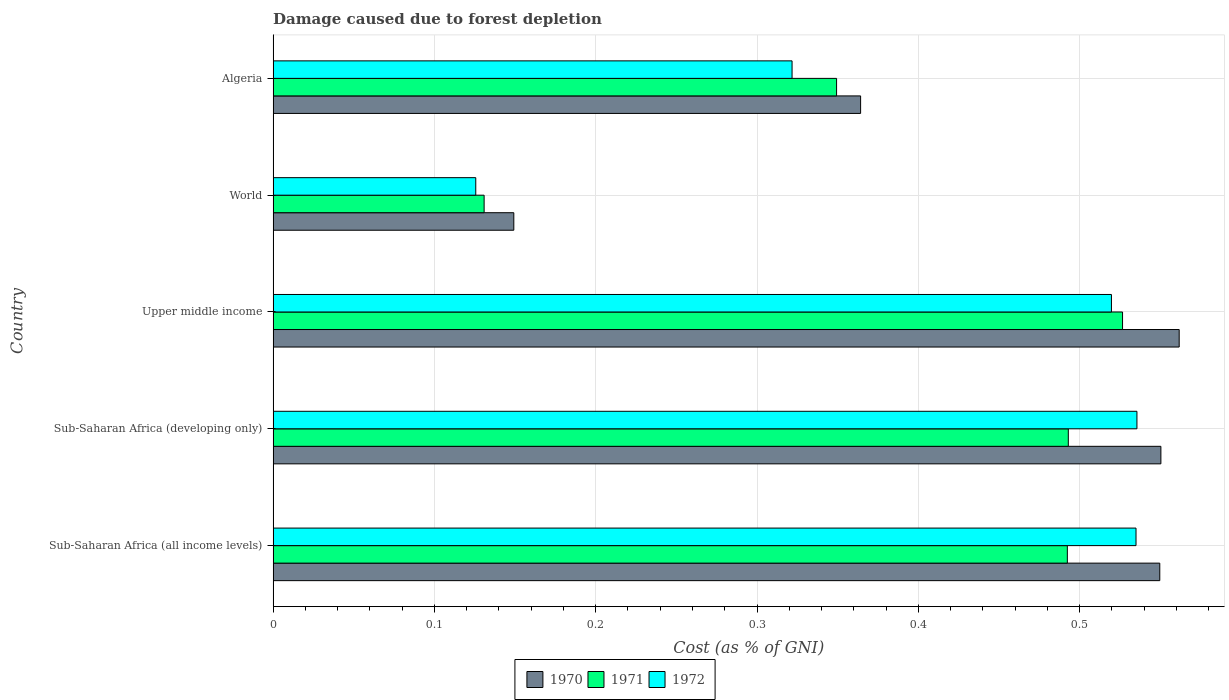How many different coloured bars are there?
Give a very brief answer. 3. How many bars are there on the 4th tick from the top?
Provide a short and direct response. 3. How many bars are there on the 4th tick from the bottom?
Your response must be concise. 3. What is the label of the 5th group of bars from the top?
Offer a terse response. Sub-Saharan Africa (all income levels). What is the cost of damage caused due to forest depletion in 1971 in World?
Provide a succinct answer. 0.13. Across all countries, what is the maximum cost of damage caused due to forest depletion in 1972?
Offer a terse response. 0.54. Across all countries, what is the minimum cost of damage caused due to forest depletion in 1970?
Make the answer very short. 0.15. In which country was the cost of damage caused due to forest depletion in 1970 maximum?
Keep it short and to the point. Upper middle income. What is the total cost of damage caused due to forest depletion in 1971 in the graph?
Your answer should be very brief. 1.99. What is the difference between the cost of damage caused due to forest depletion in 1971 in Sub-Saharan Africa (developing only) and that in World?
Your response must be concise. 0.36. What is the difference between the cost of damage caused due to forest depletion in 1971 in Sub-Saharan Africa (developing only) and the cost of damage caused due to forest depletion in 1970 in Sub-Saharan Africa (all income levels)?
Your response must be concise. -0.06. What is the average cost of damage caused due to forest depletion in 1971 per country?
Provide a short and direct response. 0.4. What is the difference between the cost of damage caused due to forest depletion in 1972 and cost of damage caused due to forest depletion in 1970 in Sub-Saharan Africa (all income levels)?
Provide a short and direct response. -0.01. In how many countries, is the cost of damage caused due to forest depletion in 1972 greater than 0.44 %?
Keep it short and to the point. 3. What is the ratio of the cost of damage caused due to forest depletion in 1970 in Sub-Saharan Africa (all income levels) to that in World?
Your answer should be compact. 3.68. Is the cost of damage caused due to forest depletion in 1972 in Sub-Saharan Africa (developing only) less than that in World?
Provide a succinct answer. No. What is the difference between the highest and the second highest cost of damage caused due to forest depletion in 1972?
Your response must be concise. 0. What is the difference between the highest and the lowest cost of damage caused due to forest depletion in 1972?
Give a very brief answer. 0.41. Is it the case that in every country, the sum of the cost of damage caused due to forest depletion in 1970 and cost of damage caused due to forest depletion in 1972 is greater than the cost of damage caused due to forest depletion in 1971?
Your response must be concise. Yes. How many bars are there?
Ensure brevity in your answer.  15. Are all the bars in the graph horizontal?
Offer a terse response. Yes. How many countries are there in the graph?
Offer a terse response. 5. Are the values on the major ticks of X-axis written in scientific E-notation?
Ensure brevity in your answer.  No. Where does the legend appear in the graph?
Your answer should be very brief. Bottom center. How many legend labels are there?
Provide a succinct answer. 3. What is the title of the graph?
Offer a terse response. Damage caused due to forest depletion. What is the label or title of the X-axis?
Provide a succinct answer. Cost (as % of GNI). What is the Cost (as % of GNI) in 1970 in Sub-Saharan Africa (all income levels)?
Your response must be concise. 0.55. What is the Cost (as % of GNI) of 1971 in Sub-Saharan Africa (all income levels)?
Provide a succinct answer. 0.49. What is the Cost (as % of GNI) in 1972 in Sub-Saharan Africa (all income levels)?
Keep it short and to the point. 0.53. What is the Cost (as % of GNI) in 1970 in Sub-Saharan Africa (developing only)?
Keep it short and to the point. 0.55. What is the Cost (as % of GNI) of 1971 in Sub-Saharan Africa (developing only)?
Give a very brief answer. 0.49. What is the Cost (as % of GNI) of 1972 in Sub-Saharan Africa (developing only)?
Make the answer very short. 0.54. What is the Cost (as % of GNI) of 1970 in Upper middle income?
Your answer should be very brief. 0.56. What is the Cost (as % of GNI) of 1971 in Upper middle income?
Your response must be concise. 0.53. What is the Cost (as % of GNI) of 1972 in Upper middle income?
Keep it short and to the point. 0.52. What is the Cost (as % of GNI) of 1970 in World?
Ensure brevity in your answer.  0.15. What is the Cost (as % of GNI) in 1971 in World?
Provide a succinct answer. 0.13. What is the Cost (as % of GNI) in 1972 in World?
Keep it short and to the point. 0.13. What is the Cost (as % of GNI) of 1970 in Algeria?
Ensure brevity in your answer.  0.36. What is the Cost (as % of GNI) of 1971 in Algeria?
Ensure brevity in your answer.  0.35. What is the Cost (as % of GNI) in 1972 in Algeria?
Offer a very short reply. 0.32. Across all countries, what is the maximum Cost (as % of GNI) of 1970?
Ensure brevity in your answer.  0.56. Across all countries, what is the maximum Cost (as % of GNI) in 1971?
Your answer should be compact. 0.53. Across all countries, what is the maximum Cost (as % of GNI) of 1972?
Your answer should be very brief. 0.54. Across all countries, what is the minimum Cost (as % of GNI) of 1970?
Your answer should be compact. 0.15. Across all countries, what is the minimum Cost (as % of GNI) of 1971?
Provide a succinct answer. 0.13. Across all countries, what is the minimum Cost (as % of GNI) in 1972?
Your answer should be compact. 0.13. What is the total Cost (as % of GNI) in 1970 in the graph?
Keep it short and to the point. 2.18. What is the total Cost (as % of GNI) of 1971 in the graph?
Your response must be concise. 1.99. What is the total Cost (as % of GNI) in 1972 in the graph?
Give a very brief answer. 2.04. What is the difference between the Cost (as % of GNI) in 1970 in Sub-Saharan Africa (all income levels) and that in Sub-Saharan Africa (developing only)?
Give a very brief answer. -0. What is the difference between the Cost (as % of GNI) in 1971 in Sub-Saharan Africa (all income levels) and that in Sub-Saharan Africa (developing only)?
Your answer should be compact. -0. What is the difference between the Cost (as % of GNI) of 1972 in Sub-Saharan Africa (all income levels) and that in Sub-Saharan Africa (developing only)?
Your answer should be very brief. -0. What is the difference between the Cost (as % of GNI) in 1970 in Sub-Saharan Africa (all income levels) and that in Upper middle income?
Make the answer very short. -0.01. What is the difference between the Cost (as % of GNI) in 1971 in Sub-Saharan Africa (all income levels) and that in Upper middle income?
Give a very brief answer. -0.03. What is the difference between the Cost (as % of GNI) of 1972 in Sub-Saharan Africa (all income levels) and that in Upper middle income?
Make the answer very short. 0.02. What is the difference between the Cost (as % of GNI) of 1970 in Sub-Saharan Africa (all income levels) and that in World?
Keep it short and to the point. 0.4. What is the difference between the Cost (as % of GNI) of 1971 in Sub-Saharan Africa (all income levels) and that in World?
Provide a succinct answer. 0.36. What is the difference between the Cost (as % of GNI) in 1972 in Sub-Saharan Africa (all income levels) and that in World?
Provide a succinct answer. 0.41. What is the difference between the Cost (as % of GNI) in 1970 in Sub-Saharan Africa (all income levels) and that in Algeria?
Ensure brevity in your answer.  0.19. What is the difference between the Cost (as % of GNI) in 1971 in Sub-Saharan Africa (all income levels) and that in Algeria?
Provide a succinct answer. 0.14. What is the difference between the Cost (as % of GNI) of 1972 in Sub-Saharan Africa (all income levels) and that in Algeria?
Keep it short and to the point. 0.21. What is the difference between the Cost (as % of GNI) of 1970 in Sub-Saharan Africa (developing only) and that in Upper middle income?
Keep it short and to the point. -0.01. What is the difference between the Cost (as % of GNI) of 1971 in Sub-Saharan Africa (developing only) and that in Upper middle income?
Your answer should be very brief. -0.03. What is the difference between the Cost (as % of GNI) of 1972 in Sub-Saharan Africa (developing only) and that in Upper middle income?
Give a very brief answer. 0.02. What is the difference between the Cost (as % of GNI) in 1970 in Sub-Saharan Africa (developing only) and that in World?
Offer a terse response. 0.4. What is the difference between the Cost (as % of GNI) in 1971 in Sub-Saharan Africa (developing only) and that in World?
Keep it short and to the point. 0.36. What is the difference between the Cost (as % of GNI) in 1972 in Sub-Saharan Africa (developing only) and that in World?
Your answer should be compact. 0.41. What is the difference between the Cost (as % of GNI) of 1970 in Sub-Saharan Africa (developing only) and that in Algeria?
Make the answer very short. 0.19. What is the difference between the Cost (as % of GNI) of 1971 in Sub-Saharan Africa (developing only) and that in Algeria?
Your answer should be compact. 0.14. What is the difference between the Cost (as % of GNI) in 1972 in Sub-Saharan Africa (developing only) and that in Algeria?
Your answer should be compact. 0.21. What is the difference between the Cost (as % of GNI) in 1970 in Upper middle income and that in World?
Offer a very short reply. 0.41. What is the difference between the Cost (as % of GNI) in 1971 in Upper middle income and that in World?
Keep it short and to the point. 0.4. What is the difference between the Cost (as % of GNI) in 1972 in Upper middle income and that in World?
Offer a very short reply. 0.39. What is the difference between the Cost (as % of GNI) of 1970 in Upper middle income and that in Algeria?
Offer a very short reply. 0.2. What is the difference between the Cost (as % of GNI) of 1971 in Upper middle income and that in Algeria?
Ensure brevity in your answer.  0.18. What is the difference between the Cost (as % of GNI) of 1972 in Upper middle income and that in Algeria?
Provide a short and direct response. 0.2. What is the difference between the Cost (as % of GNI) of 1970 in World and that in Algeria?
Keep it short and to the point. -0.21. What is the difference between the Cost (as % of GNI) in 1971 in World and that in Algeria?
Your answer should be compact. -0.22. What is the difference between the Cost (as % of GNI) of 1972 in World and that in Algeria?
Your answer should be compact. -0.2. What is the difference between the Cost (as % of GNI) in 1970 in Sub-Saharan Africa (all income levels) and the Cost (as % of GNI) in 1971 in Sub-Saharan Africa (developing only)?
Offer a terse response. 0.06. What is the difference between the Cost (as % of GNI) in 1970 in Sub-Saharan Africa (all income levels) and the Cost (as % of GNI) in 1972 in Sub-Saharan Africa (developing only)?
Offer a terse response. 0.01. What is the difference between the Cost (as % of GNI) in 1971 in Sub-Saharan Africa (all income levels) and the Cost (as % of GNI) in 1972 in Sub-Saharan Africa (developing only)?
Your answer should be compact. -0.04. What is the difference between the Cost (as % of GNI) in 1970 in Sub-Saharan Africa (all income levels) and the Cost (as % of GNI) in 1971 in Upper middle income?
Your answer should be very brief. 0.02. What is the difference between the Cost (as % of GNI) of 1970 in Sub-Saharan Africa (all income levels) and the Cost (as % of GNI) of 1972 in Upper middle income?
Your answer should be compact. 0.03. What is the difference between the Cost (as % of GNI) in 1971 in Sub-Saharan Africa (all income levels) and the Cost (as % of GNI) in 1972 in Upper middle income?
Your answer should be very brief. -0.03. What is the difference between the Cost (as % of GNI) in 1970 in Sub-Saharan Africa (all income levels) and the Cost (as % of GNI) in 1971 in World?
Offer a terse response. 0.42. What is the difference between the Cost (as % of GNI) of 1970 in Sub-Saharan Africa (all income levels) and the Cost (as % of GNI) of 1972 in World?
Offer a terse response. 0.42. What is the difference between the Cost (as % of GNI) of 1971 in Sub-Saharan Africa (all income levels) and the Cost (as % of GNI) of 1972 in World?
Give a very brief answer. 0.37. What is the difference between the Cost (as % of GNI) of 1970 in Sub-Saharan Africa (all income levels) and the Cost (as % of GNI) of 1971 in Algeria?
Your answer should be very brief. 0.2. What is the difference between the Cost (as % of GNI) of 1970 in Sub-Saharan Africa (all income levels) and the Cost (as % of GNI) of 1972 in Algeria?
Your response must be concise. 0.23. What is the difference between the Cost (as % of GNI) of 1971 in Sub-Saharan Africa (all income levels) and the Cost (as % of GNI) of 1972 in Algeria?
Your response must be concise. 0.17. What is the difference between the Cost (as % of GNI) of 1970 in Sub-Saharan Africa (developing only) and the Cost (as % of GNI) of 1971 in Upper middle income?
Provide a short and direct response. 0.02. What is the difference between the Cost (as % of GNI) in 1970 in Sub-Saharan Africa (developing only) and the Cost (as % of GNI) in 1972 in Upper middle income?
Provide a succinct answer. 0.03. What is the difference between the Cost (as % of GNI) in 1971 in Sub-Saharan Africa (developing only) and the Cost (as % of GNI) in 1972 in Upper middle income?
Provide a succinct answer. -0.03. What is the difference between the Cost (as % of GNI) in 1970 in Sub-Saharan Africa (developing only) and the Cost (as % of GNI) in 1971 in World?
Provide a short and direct response. 0.42. What is the difference between the Cost (as % of GNI) of 1970 in Sub-Saharan Africa (developing only) and the Cost (as % of GNI) of 1972 in World?
Your response must be concise. 0.42. What is the difference between the Cost (as % of GNI) in 1971 in Sub-Saharan Africa (developing only) and the Cost (as % of GNI) in 1972 in World?
Your answer should be very brief. 0.37. What is the difference between the Cost (as % of GNI) of 1970 in Sub-Saharan Africa (developing only) and the Cost (as % of GNI) of 1971 in Algeria?
Your response must be concise. 0.2. What is the difference between the Cost (as % of GNI) in 1970 in Sub-Saharan Africa (developing only) and the Cost (as % of GNI) in 1972 in Algeria?
Keep it short and to the point. 0.23. What is the difference between the Cost (as % of GNI) in 1971 in Sub-Saharan Africa (developing only) and the Cost (as % of GNI) in 1972 in Algeria?
Ensure brevity in your answer.  0.17. What is the difference between the Cost (as % of GNI) in 1970 in Upper middle income and the Cost (as % of GNI) in 1971 in World?
Your answer should be very brief. 0.43. What is the difference between the Cost (as % of GNI) in 1970 in Upper middle income and the Cost (as % of GNI) in 1972 in World?
Provide a short and direct response. 0.44. What is the difference between the Cost (as % of GNI) in 1971 in Upper middle income and the Cost (as % of GNI) in 1972 in World?
Your answer should be very brief. 0.4. What is the difference between the Cost (as % of GNI) in 1970 in Upper middle income and the Cost (as % of GNI) in 1971 in Algeria?
Ensure brevity in your answer.  0.21. What is the difference between the Cost (as % of GNI) in 1970 in Upper middle income and the Cost (as % of GNI) in 1972 in Algeria?
Keep it short and to the point. 0.24. What is the difference between the Cost (as % of GNI) in 1971 in Upper middle income and the Cost (as % of GNI) in 1972 in Algeria?
Offer a terse response. 0.2. What is the difference between the Cost (as % of GNI) of 1970 in World and the Cost (as % of GNI) of 1971 in Algeria?
Keep it short and to the point. -0.2. What is the difference between the Cost (as % of GNI) in 1970 in World and the Cost (as % of GNI) in 1972 in Algeria?
Give a very brief answer. -0.17. What is the difference between the Cost (as % of GNI) of 1971 in World and the Cost (as % of GNI) of 1972 in Algeria?
Give a very brief answer. -0.19. What is the average Cost (as % of GNI) of 1970 per country?
Offer a very short reply. 0.43. What is the average Cost (as % of GNI) of 1971 per country?
Keep it short and to the point. 0.4. What is the average Cost (as % of GNI) of 1972 per country?
Your response must be concise. 0.41. What is the difference between the Cost (as % of GNI) in 1970 and Cost (as % of GNI) in 1971 in Sub-Saharan Africa (all income levels)?
Your answer should be very brief. 0.06. What is the difference between the Cost (as % of GNI) in 1970 and Cost (as % of GNI) in 1972 in Sub-Saharan Africa (all income levels)?
Provide a short and direct response. 0.01. What is the difference between the Cost (as % of GNI) in 1971 and Cost (as % of GNI) in 1972 in Sub-Saharan Africa (all income levels)?
Offer a terse response. -0.04. What is the difference between the Cost (as % of GNI) of 1970 and Cost (as % of GNI) of 1971 in Sub-Saharan Africa (developing only)?
Offer a very short reply. 0.06. What is the difference between the Cost (as % of GNI) in 1970 and Cost (as % of GNI) in 1972 in Sub-Saharan Africa (developing only)?
Keep it short and to the point. 0.01. What is the difference between the Cost (as % of GNI) of 1971 and Cost (as % of GNI) of 1972 in Sub-Saharan Africa (developing only)?
Offer a terse response. -0.04. What is the difference between the Cost (as % of GNI) in 1970 and Cost (as % of GNI) in 1971 in Upper middle income?
Your answer should be very brief. 0.04. What is the difference between the Cost (as % of GNI) in 1970 and Cost (as % of GNI) in 1972 in Upper middle income?
Offer a very short reply. 0.04. What is the difference between the Cost (as % of GNI) of 1971 and Cost (as % of GNI) of 1972 in Upper middle income?
Offer a terse response. 0.01. What is the difference between the Cost (as % of GNI) in 1970 and Cost (as % of GNI) in 1971 in World?
Make the answer very short. 0.02. What is the difference between the Cost (as % of GNI) in 1970 and Cost (as % of GNI) in 1972 in World?
Offer a very short reply. 0.02. What is the difference between the Cost (as % of GNI) in 1971 and Cost (as % of GNI) in 1972 in World?
Offer a terse response. 0.01. What is the difference between the Cost (as % of GNI) of 1970 and Cost (as % of GNI) of 1971 in Algeria?
Provide a short and direct response. 0.01. What is the difference between the Cost (as % of GNI) of 1970 and Cost (as % of GNI) of 1972 in Algeria?
Keep it short and to the point. 0.04. What is the difference between the Cost (as % of GNI) in 1971 and Cost (as % of GNI) in 1972 in Algeria?
Offer a very short reply. 0.03. What is the ratio of the Cost (as % of GNI) of 1970 in Sub-Saharan Africa (all income levels) to that in Sub-Saharan Africa (developing only)?
Provide a short and direct response. 1. What is the ratio of the Cost (as % of GNI) in 1971 in Sub-Saharan Africa (all income levels) to that in Sub-Saharan Africa (developing only)?
Your answer should be very brief. 1. What is the ratio of the Cost (as % of GNI) of 1970 in Sub-Saharan Africa (all income levels) to that in Upper middle income?
Keep it short and to the point. 0.98. What is the ratio of the Cost (as % of GNI) of 1971 in Sub-Saharan Africa (all income levels) to that in Upper middle income?
Keep it short and to the point. 0.94. What is the ratio of the Cost (as % of GNI) in 1972 in Sub-Saharan Africa (all income levels) to that in Upper middle income?
Provide a short and direct response. 1.03. What is the ratio of the Cost (as % of GNI) in 1970 in Sub-Saharan Africa (all income levels) to that in World?
Provide a succinct answer. 3.68. What is the ratio of the Cost (as % of GNI) of 1971 in Sub-Saharan Africa (all income levels) to that in World?
Your answer should be compact. 3.76. What is the ratio of the Cost (as % of GNI) of 1972 in Sub-Saharan Africa (all income levels) to that in World?
Offer a very short reply. 4.26. What is the ratio of the Cost (as % of GNI) of 1970 in Sub-Saharan Africa (all income levels) to that in Algeria?
Give a very brief answer. 1.51. What is the ratio of the Cost (as % of GNI) of 1971 in Sub-Saharan Africa (all income levels) to that in Algeria?
Provide a short and direct response. 1.41. What is the ratio of the Cost (as % of GNI) of 1972 in Sub-Saharan Africa (all income levels) to that in Algeria?
Offer a very short reply. 1.66. What is the ratio of the Cost (as % of GNI) of 1970 in Sub-Saharan Africa (developing only) to that in Upper middle income?
Give a very brief answer. 0.98. What is the ratio of the Cost (as % of GNI) in 1971 in Sub-Saharan Africa (developing only) to that in Upper middle income?
Your answer should be compact. 0.94. What is the ratio of the Cost (as % of GNI) in 1972 in Sub-Saharan Africa (developing only) to that in Upper middle income?
Keep it short and to the point. 1.03. What is the ratio of the Cost (as % of GNI) of 1970 in Sub-Saharan Africa (developing only) to that in World?
Your response must be concise. 3.69. What is the ratio of the Cost (as % of GNI) of 1971 in Sub-Saharan Africa (developing only) to that in World?
Give a very brief answer. 3.77. What is the ratio of the Cost (as % of GNI) in 1972 in Sub-Saharan Africa (developing only) to that in World?
Your answer should be compact. 4.26. What is the ratio of the Cost (as % of GNI) of 1970 in Sub-Saharan Africa (developing only) to that in Algeria?
Your answer should be very brief. 1.51. What is the ratio of the Cost (as % of GNI) in 1971 in Sub-Saharan Africa (developing only) to that in Algeria?
Your response must be concise. 1.41. What is the ratio of the Cost (as % of GNI) in 1972 in Sub-Saharan Africa (developing only) to that in Algeria?
Ensure brevity in your answer.  1.66. What is the ratio of the Cost (as % of GNI) in 1970 in Upper middle income to that in World?
Offer a terse response. 3.76. What is the ratio of the Cost (as % of GNI) in 1971 in Upper middle income to that in World?
Provide a short and direct response. 4.03. What is the ratio of the Cost (as % of GNI) in 1972 in Upper middle income to that in World?
Your response must be concise. 4.14. What is the ratio of the Cost (as % of GNI) of 1970 in Upper middle income to that in Algeria?
Your response must be concise. 1.54. What is the ratio of the Cost (as % of GNI) of 1971 in Upper middle income to that in Algeria?
Keep it short and to the point. 1.51. What is the ratio of the Cost (as % of GNI) of 1972 in Upper middle income to that in Algeria?
Make the answer very short. 1.62. What is the ratio of the Cost (as % of GNI) in 1970 in World to that in Algeria?
Provide a succinct answer. 0.41. What is the ratio of the Cost (as % of GNI) of 1971 in World to that in Algeria?
Ensure brevity in your answer.  0.37. What is the ratio of the Cost (as % of GNI) of 1972 in World to that in Algeria?
Give a very brief answer. 0.39. What is the difference between the highest and the second highest Cost (as % of GNI) of 1970?
Provide a short and direct response. 0.01. What is the difference between the highest and the second highest Cost (as % of GNI) in 1971?
Your answer should be compact. 0.03. What is the difference between the highest and the second highest Cost (as % of GNI) in 1972?
Give a very brief answer. 0. What is the difference between the highest and the lowest Cost (as % of GNI) of 1970?
Your response must be concise. 0.41. What is the difference between the highest and the lowest Cost (as % of GNI) in 1971?
Offer a terse response. 0.4. What is the difference between the highest and the lowest Cost (as % of GNI) in 1972?
Your answer should be compact. 0.41. 